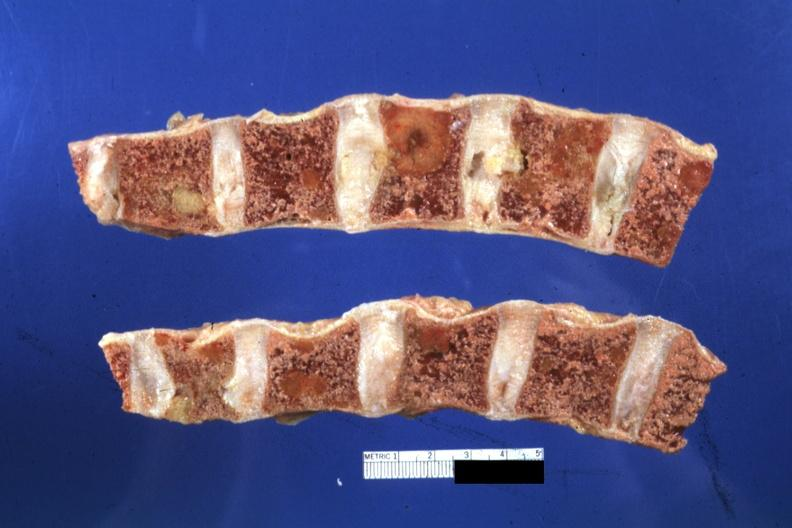what does this image show?
Answer the question using a single word or phrase. Appears fixed lesions show well 